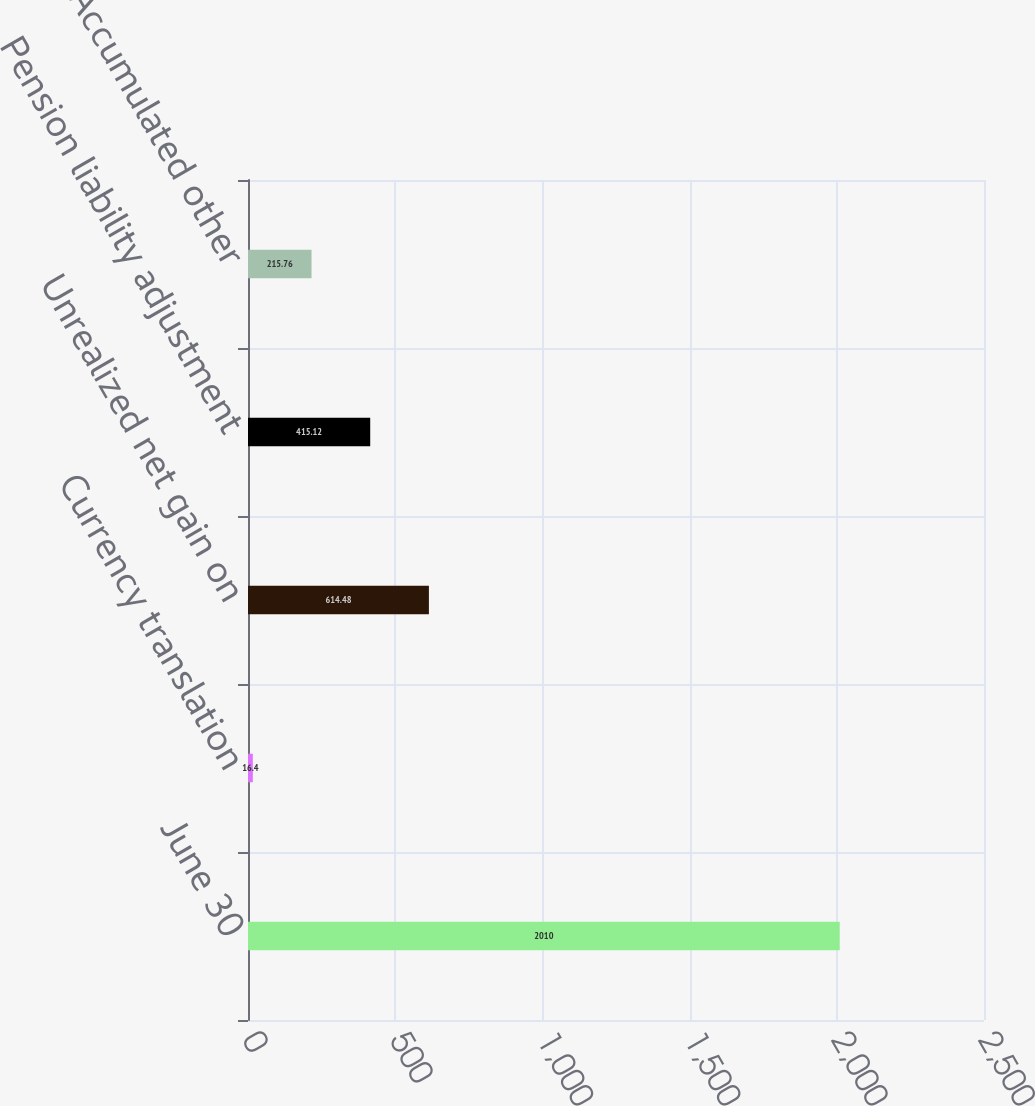Convert chart to OTSL. <chart><loc_0><loc_0><loc_500><loc_500><bar_chart><fcel>June 30<fcel>Currency translation<fcel>Unrealized net gain on<fcel>Pension liability adjustment<fcel>Accumulated other<nl><fcel>2010<fcel>16.4<fcel>614.48<fcel>415.12<fcel>215.76<nl></chart> 